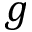<formula> <loc_0><loc_0><loc_500><loc_500>g</formula> 